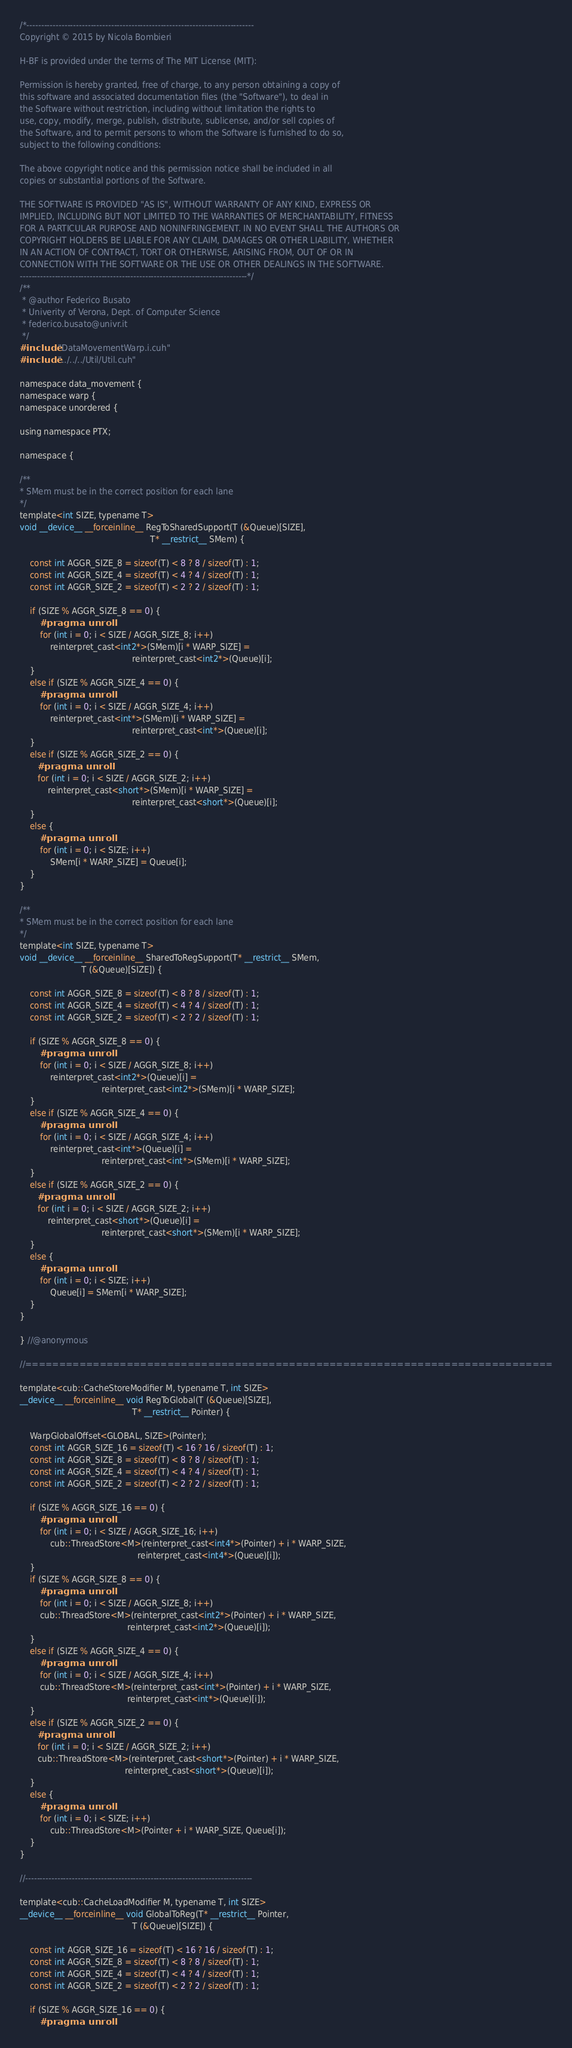Convert code to text. <code><loc_0><loc_0><loc_500><loc_500><_Cuda_>/*------------------------------------------------------------------------------
Copyright © 2015 by Nicola Bombieri

H-BF is provided under the terms of The MIT License (MIT):

Permission is hereby granted, free of charge, to any person obtaining a copy of
this software and associated documentation files (the "Software"), to deal in
the Software without restriction, including without limitation the rights to
use, copy, modify, merge, publish, distribute, sublicense, and/or sell copies of
the Software, and to permit persons to whom the Software is furnished to do so,
subject to the following conditions:

The above copyright notice and this permission notice shall be included in all
copies or substantial portions of the Software.

THE SOFTWARE IS PROVIDED "AS IS", WITHOUT WARRANTY OF ANY KIND, EXPRESS OR
IMPLIED, INCLUDING BUT NOT LIMITED TO THE WARRANTIES OF MERCHANTABILITY, FITNESS
FOR A PARTICULAR PURPOSE AND NONINFRINGEMENT. IN NO EVENT SHALL THE AUTHORS OR
COPYRIGHT HOLDERS BE LIABLE FOR ANY CLAIM, DAMAGES OR OTHER LIABILITY, WHETHER
IN AN ACTION OF CONTRACT, TORT OR OTHERWISE, ARISING FROM, OUT OF OR IN
CONNECTION WITH THE SOFTWARE OR THE USE OR OTHER DEALINGS IN THE SOFTWARE.
------------------------------------------------------------------------------*/
/**
 * @author Federico Busato
 * Univerity of Verona, Dept. of Computer Science
 * federico.busato@univr.it
 */
#include "DataMovementWarp.i.cuh"
#include "../../../Util/Util.cuh"

namespace data_movement {
namespace warp {
namespace unordered {

using namespace PTX;

namespace {

/**
* SMem must be in the correct position for each lane
*/
template<int SIZE, typename T>
void __device__ __forceinline__ RegToSharedSupport(T (&Queue)[SIZE],
                                                   T* __restrict__ SMem) {

    const int AGGR_SIZE_8 = sizeof(T) < 8 ? 8 / sizeof(T) : 1;
    const int AGGR_SIZE_4 = sizeof(T) < 4 ? 4 / sizeof(T) : 1;
    const int AGGR_SIZE_2 = sizeof(T) < 2 ? 2 / sizeof(T) : 1;

    if (SIZE % AGGR_SIZE_8 == 0) {
        #pragma unroll
        for (int i = 0; i < SIZE / AGGR_SIZE_8; i++)
            reinterpret_cast<int2*>(SMem)[i * WARP_SIZE] =
                                            reinterpret_cast<int2*>(Queue)[i];
    }
    else if (SIZE % AGGR_SIZE_4 == 0) {
        #pragma unroll
        for (int i = 0; i < SIZE / AGGR_SIZE_4; i++)
            reinterpret_cast<int*>(SMem)[i * WARP_SIZE] =
                                            reinterpret_cast<int*>(Queue)[i];
    }
    else if (SIZE % AGGR_SIZE_2 == 0) {
       #pragma unroll
       for (int i = 0; i < SIZE / AGGR_SIZE_2; i++)
           reinterpret_cast<short*>(SMem)[i * WARP_SIZE] =
                                            reinterpret_cast<short*>(Queue)[i];
    }
    else {
        #pragma unroll
        for (int i = 0; i < SIZE; i++)
            SMem[i * WARP_SIZE] = Queue[i];
    }
}

/**
* SMem must be in the correct position for each lane
*/
template<int SIZE, typename T>
void __device__ __forceinline__ SharedToRegSupport(T* __restrict__ SMem,
                        T (&Queue)[SIZE]) {

    const int AGGR_SIZE_8 = sizeof(T) < 8 ? 8 / sizeof(T) : 1;
    const int AGGR_SIZE_4 = sizeof(T) < 4 ? 4 / sizeof(T) : 1;
    const int AGGR_SIZE_2 = sizeof(T) < 2 ? 2 / sizeof(T) : 1;

    if (SIZE % AGGR_SIZE_8 == 0) {
        #pragma unroll
        for (int i = 0; i < SIZE / AGGR_SIZE_8; i++)
            reinterpret_cast<int2*>(Queue)[i] =
                                reinterpret_cast<int2*>(SMem)[i * WARP_SIZE];
    }
    else if (SIZE % AGGR_SIZE_4 == 0) {
        #pragma unroll
        for (int i = 0; i < SIZE / AGGR_SIZE_4; i++)
            reinterpret_cast<int*>(Queue)[i] =
                                reinterpret_cast<int*>(SMem)[i * WARP_SIZE];
    }
    else if (SIZE % AGGR_SIZE_2 == 0) {
       #pragma unroll
       for (int i = 0; i < SIZE / AGGR_SIZE_2; i++)
           reinterpret_cast<short*>(Queue)[i] =
                                reinterpret_cast<short*>(SMem)[i * WARP_SIZE];
    }
    else {
        #pragma unroll
        for (int i = 0; i < SIZE; i++)
            Queue[i] = SMem[i * WARP_SIZE];
    }
}

} //@anonymous

//==============================================================================

template<cub::CacheStoreModifier M, typename T, int SIZE>
__device__ __forceinline__ void RegToGlobal(T (&Queue)[SIZE],
                                            T* __restrict__ Pointer) {

    WarpGlobalOffset<GLOBAL, SIZE>(Pointer);
    const int AGGR_SIZE_16 = sizeof(T) < 16 ? 16 / sizeof(T) : 1;
    const int AGGR_SIZE_8 = sizeof(T) < 8 ? 8 / sizeof(T) : 1;
    const int AGGR_SIZE_4 = sizeof(T) < 4 ? 4 / sizeof(T) : 1;
    const int AGGR_SIZE_2 = sizeof(T) < 2 ? 2 / sizeof(T) : 1;

    if (SIZE % AGGR_SIZE_16 == 0) {
        #pragma unroll
        for (int i = 0; i < SIZE / AGGR_SIZE_16; i++)
            cub::ThreadStore<M>(reinterpret_cast<int4*>(Pointer) + i * WARP_SIZE,
                                              reinterpret_cast<int4*>(Queue)[i]);
    }
    if (SIZE % AGGR_SIZE_8 == 0) {
        #pragma unroll
        for (int i = 0; i < SIZE / AGGR_SIZE_8; i++)
        cub::ThreadStore<M>(reinterpret_cast<int2*>(Pointer) + i * WARP_SIZE,
                                          reinterpret_cast<int2*>(Queue)[i]);
    }
    else if (SIZE % AGGR_SIZE_4 == 0) {
        #pragma unroll
        for (int i = 0; i < SIZE / AGGR_SIZE_4; i++)
        cub::ThreadStore<M>(reinterpret_cast<int*>(Pointer) + i * WARP_SIZE,
                                          reinterpret_cast<int*>(Queue)[i]);
    }
    else if (SIZE % AGGR_SIZE_2 == 0) {
       #pragma unroll
       for (int i = 0; i < SIZE / AGGR_SIZE_2; i++)
       cub::ThreadStore<M>(reinterpret_cast<short*>(Pointer) + i * WARP_SIZE,
                                         reinterpret_cast<short*>(Queue)[i]);
    }
    else {
        #pragma unroll
        for (int i = 0; i < SIZE; i++)
            cub::ThreadStore<M>(Pointer + i * WARP_SIZE, Queue[i]);
    }
}

//------------------------------------------------------------------------------

template<cub::CacheLoadModifier M, typename T, int SIZE>
__device__ __forceinline__ void GlobalToReg(T* __restrict__ Pointer,
                                            T (&Queue)[SIZE]) {

    const int AGGR_SIZE_16 = sizeof(T) < 16 ? 16 / sizeof(T) : 1;
    const int AGGR_SIZE_8 = sizeof(T) < 8 ? 8 / sizeof(T) : 1;
    const int AGGR_SIZE_4 = sizeof(T) < 4 ? 4 / sizeof(T) : 1;
    const int AGGR_SIZE_2 = sizeof(T) < 2 ? 2 / sizeof(T) : 1;

    if (SIZE % AGGR_SIZE_16 == 0) {
        #pragma unroll</code> 